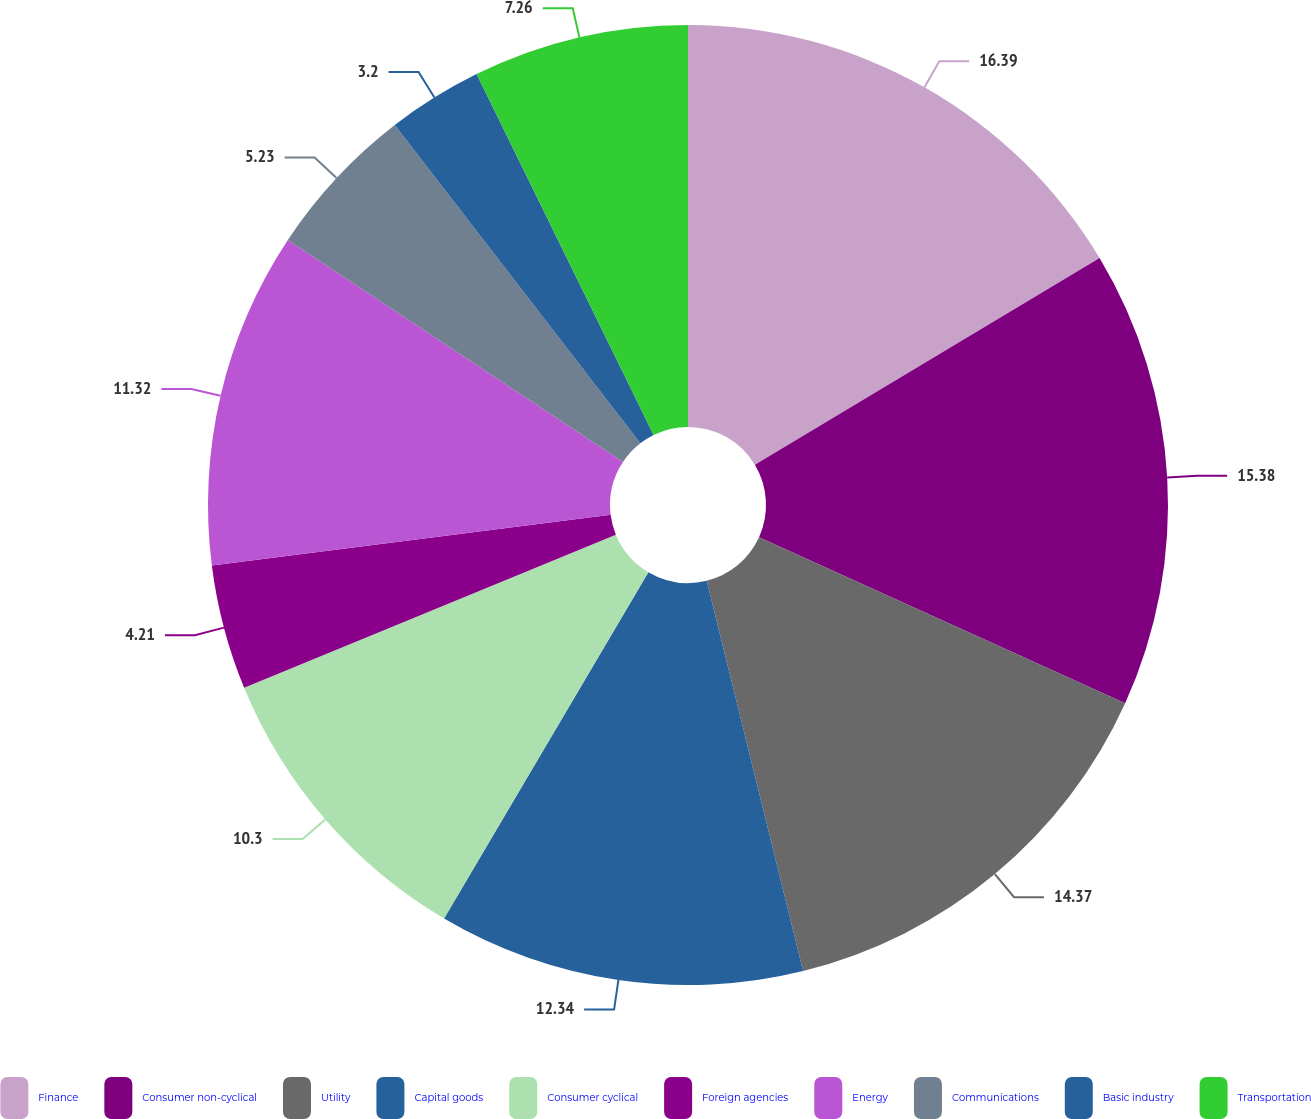<chart> <loc_0><loc_0><loc_500><loc_500><pie_chart><fcel>Finance<fcel>Consumer non-cyclical<fcel>Utility<fcel>Capital goods<fcel>Consumer cyclical<fcel>Foreign agencies<fcel>Energy<fcel>Communications<fcel>Basic industry<fcel>Transportation<nl><fcel>16.4%<fcel>15.38%<fcel>14.37%<fcel>12.34%<fcel>10.3%<fcel>4.21%<fcel>11.32%<fcel>5.23%<fcel>3.2%<fcel>7.26%<nl></chart> 